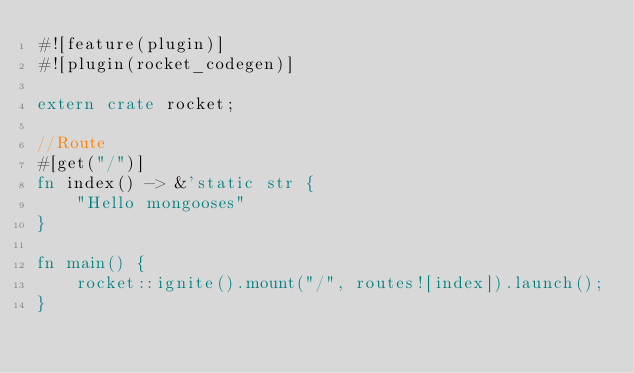<code> <loc_0><loc_0><loc_500><loc_500><_Rust_>#![feature(plugin)]
#![plugin(rocket_codegen)]

extern crate rocket;

//Route
#[get("/")]
fn index() -> &'static str {
    "Hello mongooses"
}

fn main() {
    rocket::ignite().mount("/", routes![index]).launch();
}
</code> 